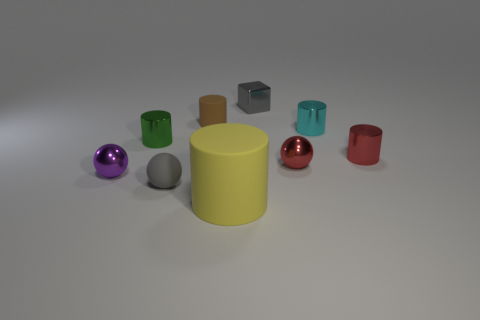Subtract all yellow cylinders. How many cylinders are left? 4 Subtract all yellow matte cylinders. How many cylinders are left? 4 Add 1 big cylinders. How many objects exist? 10 Subtract all yellow cylinders. Subtract all gray blocks. How many cylinders are left? 4 Subtract all blocks. How many objects are left? 8 Subtract all small gray spheres. Subtract all purple metal spheres. How many objects are left? 7 Add 5 tiny gray metal cubes. How many tiny gray metal cubes are left? 6 Add 7 large metal things. How many large metal things exist? 7 Subtract 1 red cylinders. How many objects are left? 8 